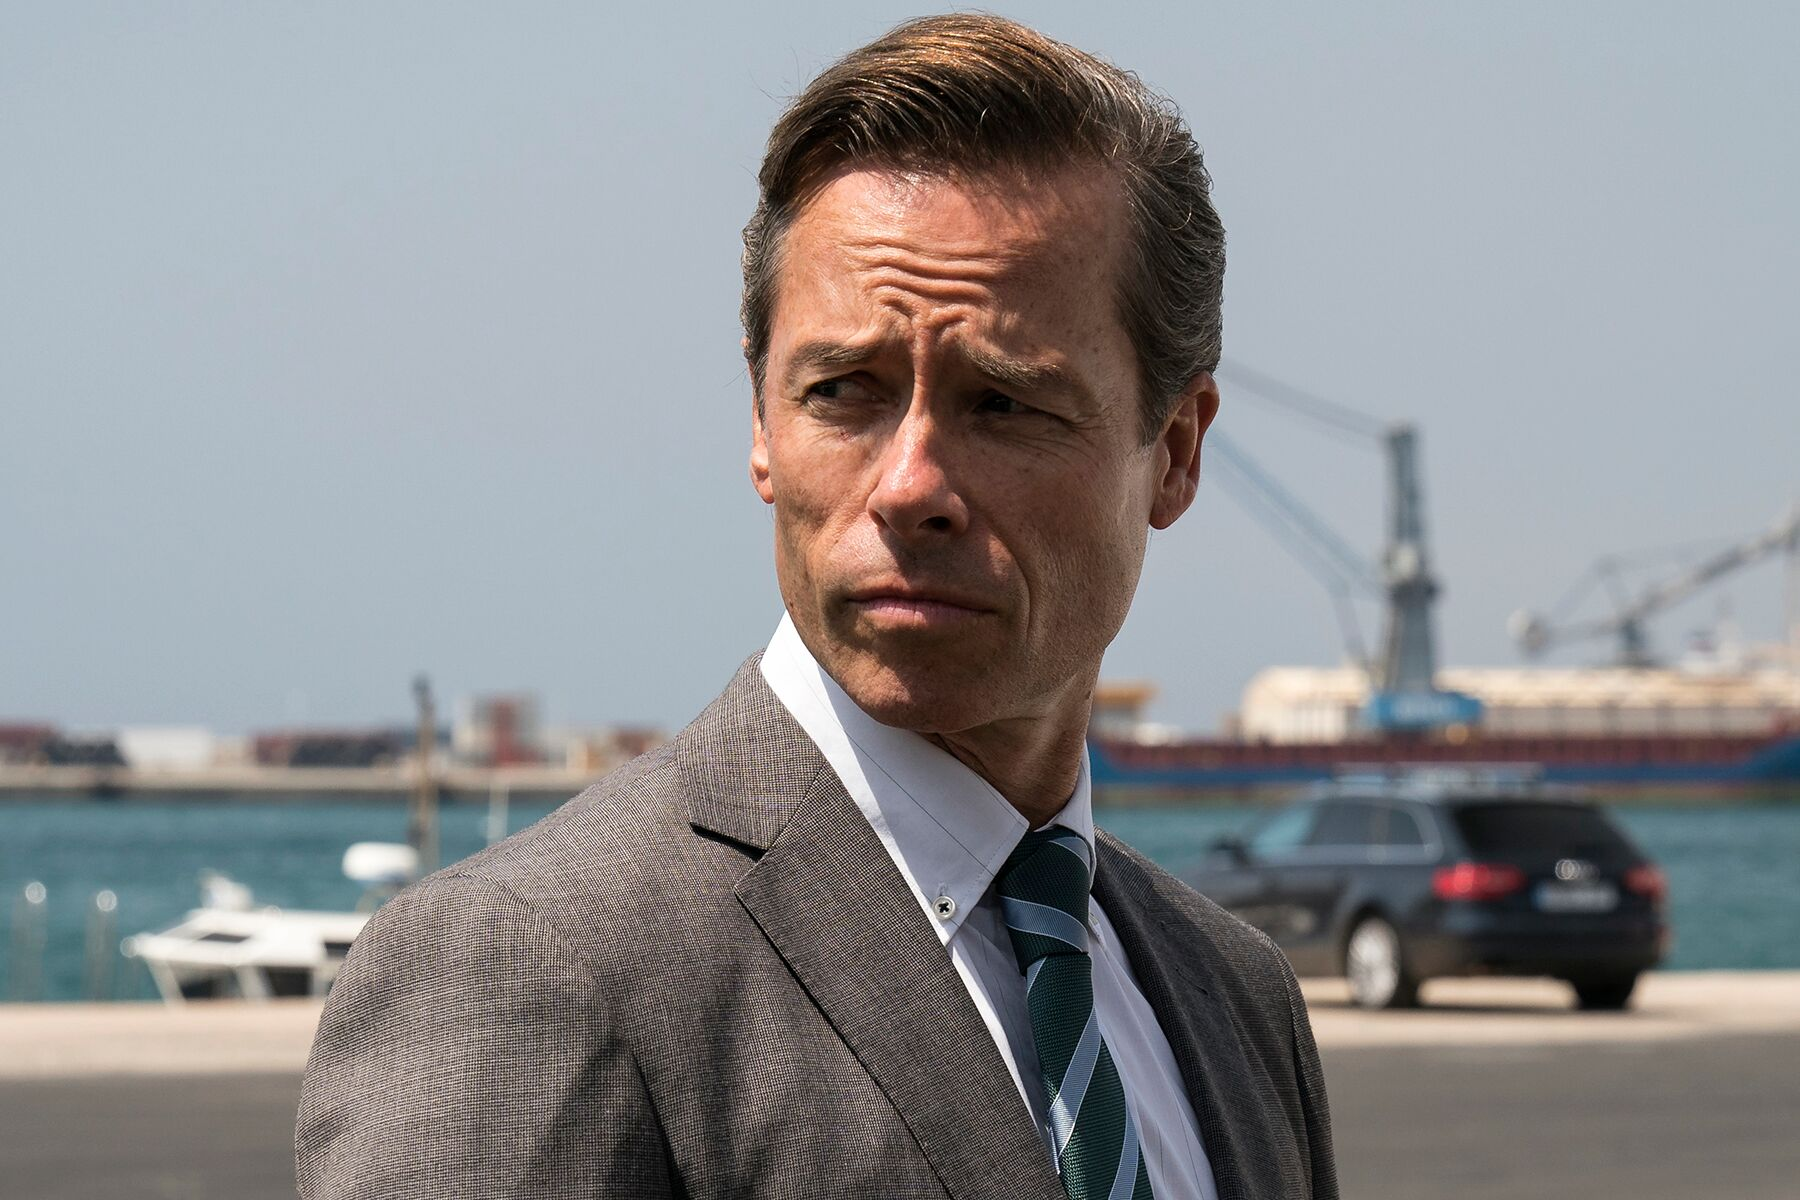Explain the visual content of the image in great detail. The image portrays a man in a professional, sharp gray suit with a green tie, standing in front of a bustling harbor, which is indicative of a busy maritime environment. The man has meticulously slicked-back hair and a serious expression, signifying deep thought or contemplation. The background of the image features a variety of boats and shipping containers, with cranes and industrial structures highlighting the busy nature of the port. The clear blue sky suggests it is a sunny day, creating a serene yet industrious atmosphere. The combination of his formal attire and the industrial background evokes a juxtaposition of human professionalism against the backdrop of maritime commerce. This scene seems to capture a pivotal moment, possibly from a film or a series, where the man's character is deeply engaged in a significant event. 